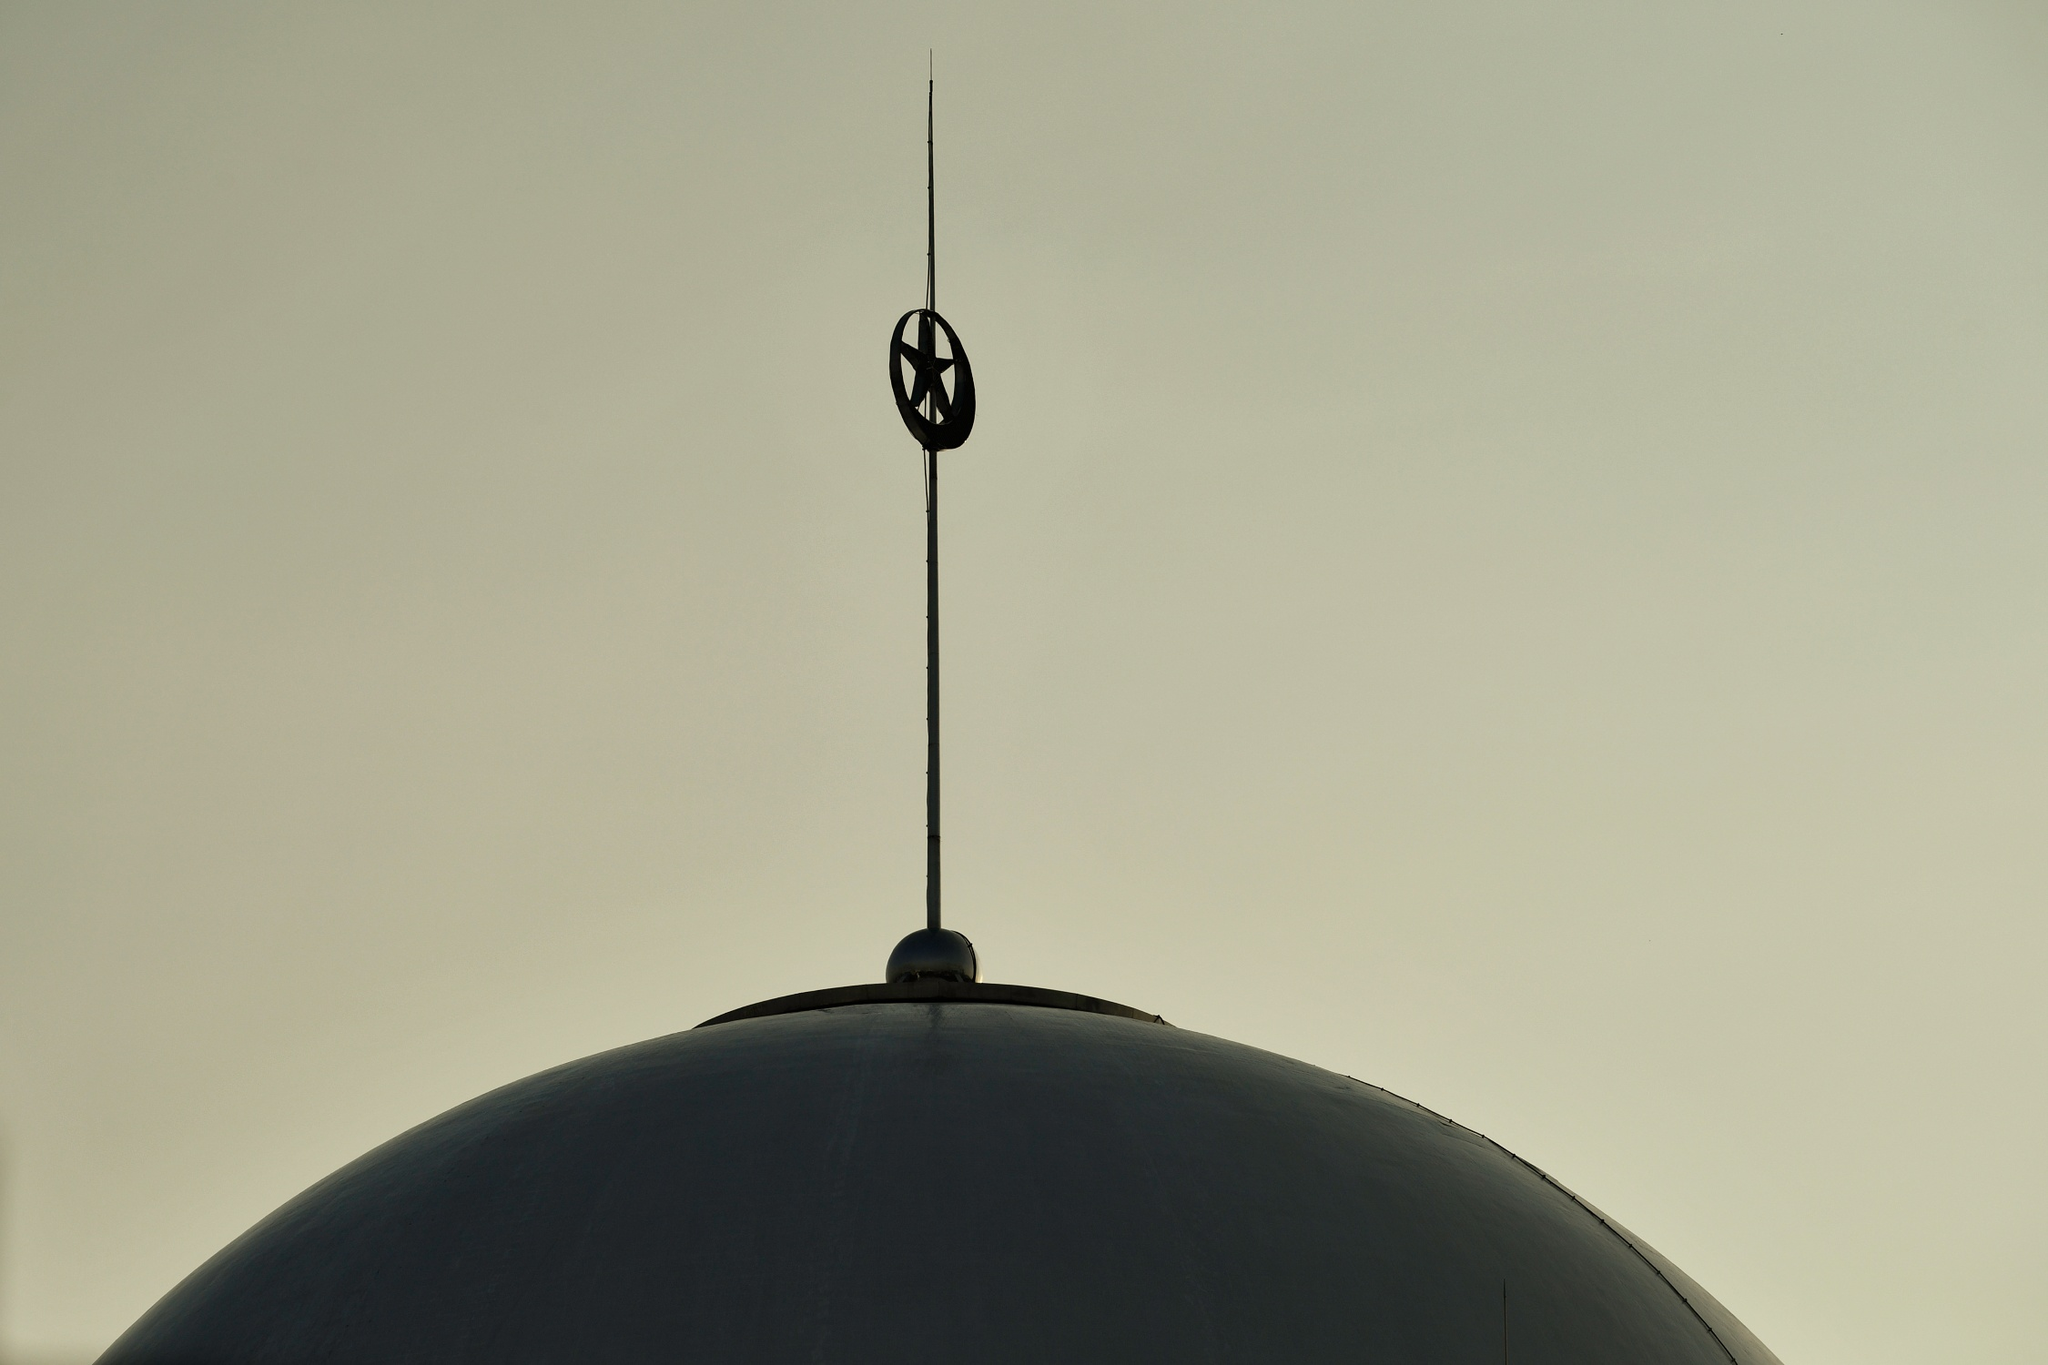Can you describe the architectural style or elements visible in the dome and spire? The dome showcases a smooth curvature suggesting a Byzantine or Ottoman influence commonly seen in domed structures of religious significance. The spire is slender and minimalist, topped with what appears to be a crescent moon finial, often indicative of Islamic architecture. Such elements contribute to the grandeur and intricacy of the structure, though the specific architectural style cannot be conclusively identified without broader context. 